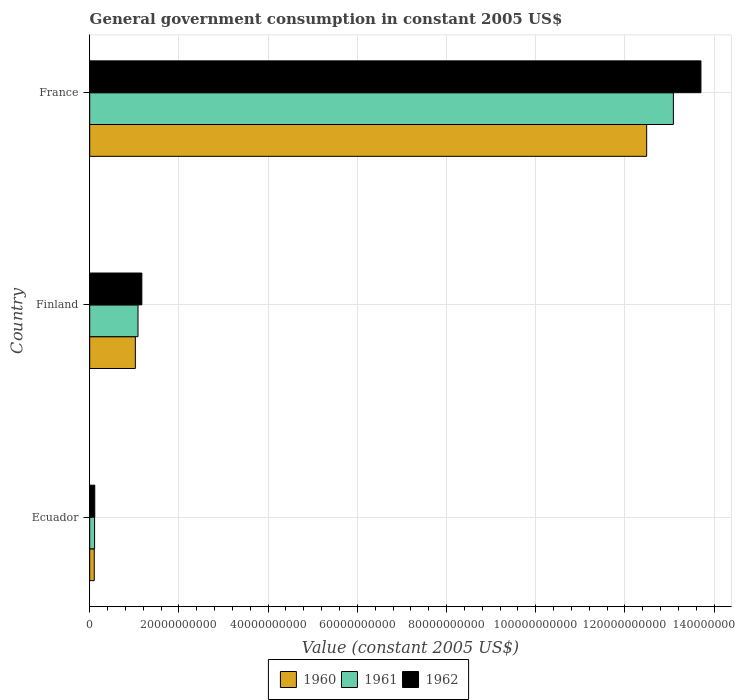How many different coloured bars are there?
Give a very brief answer. 3. How many groups of bars are there?
Offer a terse response. 3. Are the number of bars per tick equal to the number of legend labels?
Your answer should be compact. Yes. Are the number of bars on each tick of the Y-axis equal?
Keep it short and to the point. Yes. What is the label of the 3rd group of bars from the top?
Provide a succinct answer. Ecuador. What is the government conusmption in 1962 in France?
Your answer should be compact. 1.37e+11. Across all countries, what is the maximum government conusmption in 1962?
Ensure brevity in your answer.  1.37e+11. Across all countries, what is the minimum government conusmption in 1961?
Provide a short and direct response. 1.10e+09. In which country was the government conusmption in 1961 maximum?
Keep it short and to the point. France. In which country was the government conusmption in 1962 minimum?
Offer a terse response. Ecuador. What is the total government conusmption in 1960 in the graph?
Offer a terse response. 1.36e+11. What is the difference between the government conusmption in 1960 in Finland and that in France?
Offer a terse response. -1.15e+11. What is the difference between the government conusmption in 1960 in France and the government conusmption in 1961 in Finland?
Provide a succinct answer. 1.14e+11. What is the average government conusmption in 1960 per country?
Offer a very short reply. 4.54e+1. What is the difference between the government conusmption in 1960 and government conusmption in 1962 in Finland?
Provide a succinct answer. -1.46e+09. What is the ratio of the government conusmption in 1961 in Finland to that in France?
Your answer should be compact. 0.08. Is the government conusmption in 1961 in Finland less than that in France?
Offer a terse response. Yes. What is the difference between the highest and the second highest government conusmption in 1961?
Provide a short and direct response. 1.20e+11. What is the difference between the highest and the lowest government conusmption in 1960?
Ensure brevity in your answer.  1.24e+11. In how many countries, is the government conusmption in 1961 greater than the average government conusmption in 1961 taken over all countries?
Give a very brief answer. 1. Is the sum of the government conusmption in 1960 in Finland and France greater than the maximum government conusmption in 1962 across all countries?
Your response must be concise. No. What does the 2nd bar from the top in France represents?
Your answer should be very brief. 1961. Is it the case that in every country, the sum of the government conusmption in 1961 and government conusmption in 1960 is greater than the government conusmption in 1962?
Provide a succinct answer. Yes. Are all the bars in the graph horizontal?
Make the answer very short. Yes. Are the values on the major ticks of X-axis written in scientific E-notation?
Your answer should be very brief. No. Does the graph contain any zero values?
Your answer should be very brief. No. Does the graph contain grids?
Your response must be concise. Yes. Where does the legend appear in the graph?
Make the answer very short. Bottom center. What is the title of the graph?
Offer a terse response. General government consumption in constant 2005 US$. Does "1987" appear as one of the legend labels in the graph?
Your answer should be compact. No. What is the label or title of the X-axis?
Your answer should be compact. Value (constant 2005 US$). What is the Value (constant 2005 US$) of 1960 in Ecuador?
Keep it short and to the point. 1.03e+09. What is the Value (constant 2005 US$) of 1961 in Ecuador?
Provide a succinct answer. 1.10e+09. What is the Value (constant 2005 US$) in 1962 in Ecuador?
Give a very brief answer. 1.14e+09. What is the Value (constant 2005 US$) of 1960 in Finland?
Provide a short and direct response. 1.02e+1. What is the Value (constant 2005 US$) in 1961 in Finland?
Offer a terse response. 1.08e+1. What is the Value (constant 2005 US$) of 1962 in Finland?
Your answer should be very brief. 1.17e+1. What is the Value (constant 2005 US$) of 1960 in France?
Give a very brief answer. 1.25e+11. What is the Value (constant 2005 US$) of 1961 in France?
Offer a very short reply. 1.31e+11. What is the Value (constant 2005 US$) of 1962 in France?
Provide a short and direct response. 1.37e+11. Across all countries, what is the maximum Value (constant 2005 US$) of 1960?
Your answer should be compact. 1.25e+11. Across all countries, what is the maximum Value (constant 2005 US$) in 1961?
Provide a succinct answer. 1.31e+11. Across all countries, what is the maximum Value (constant 2005 US$) of 1962?
Offer a very short reply. 1.37e+11. Across all countries, what is the minimum Value (constant 2005 US$) in 1960?
Ensure brevity in your answer.  1.03e+09. Across all countries, what is the minimum Value (constant 2005 US$) of 1961?
Give a very brief answer. 1.10e+09. Across all countries, what is the minimum Value (constant 2005 US$) in 1962?
Provide a short and direct response. 1.14e+09. What is the total Value (constant 2005 US$) of 1960 in the graph?
Provide a short and direct response. 1.36e+11. What is the total Value (constant 2005 US$) of 1961 in the graph?
Provide a succinct answer. 1.43e+11. What is the total Value (constant 2005 US$) in 1962 in the graph?
Make the answer very short. 1.50e+11. What is the difference between the Value (constant 2005 US$) in 1960 in Ecuador and that in Finland?
Offer a terse response. -9.21e+09. What is the difference between the Value (constant 2005 US$) in 1961 in Ecuador and that in Finland?
Offer a very short reply. -9.73e+09. What is the difference between the Value (constant 2005 US$) of 1962 in Ecuador and that in Finland?
Provide a succinct answer. -1.06e+1. What is the difference between the Value (constant 2005 US$) in 1960 in Ecuador and that in France?
Make the answer very short. -1.24e+11. What is the difference between the Value (constant 2005 US$) of 1961 in Ecuador and that in France?
Provide a short and direct response. -1.30e+11. What is the difference between the Value (constant 2005 US$) in 1962 in Ecuador and that in France?
Make the answer very short. -1.36e+11. What is the difference between the Value (constant 2005 US$) of 1960 in Finland and that in France?
Ensure brevity in your answer.  -1.15e+11. What is the difference between the Value (constant 2005 US$) in 1961 in Finland and that in France?
Offer a very short reply. -1.20e+11. What is the difference between the Value (constant 2005 US$) in 1962 in Finland and that in France?
Your answer should be compact. -1.25e+11. What is the difference between the Value (constant 2005 US$) in 1960 in Ecuador and the Value (constant 2005 US$) in 1961 in Finland?
Ensure brevity in your answer.  -9.81e+09. What is the difference between the Value (constant 2005 US$) in 1960 in Ecuador and the Value (constant 2005 US$) in 1962 in Finland?
Your answer should be compact. -1.07e+1. What is the difference between the Value (constant 2005 US$) in 1961 in Ecuador and the Value (constant 2005 US$) in 1962 in Finland?
Ensure brevity in your answer.  -1.06e+1. What is the difference between the Value (constant 2005 US$) in 1960 in Ecuador and the Value (constant 2005 US$) in 1961 in France?
Keep it short and to the point. -1.30e+11. What is the difference between the Value (constant 2005 US$) in 1960 in Ecuador and the Value (constant 2005 US$) in 1962 in France?
Offer a very short reply. -1.36e+11. What is the difference between the Value (constant 2005 US$) in 1961 in Ecuador and the Value (constant 2005 US$) in 1962 in France?
Keep it short and to the point. -1.36e+11. What is the difference between the Value (constant 2005 US$) of 1960 in Finland and the Value (constant 2005 US$) of 1961 in France?
Your answer should be very brief. -1.21e+11. What is the difference between the Value (constant 2005 US$) in 1960 in Finland and the Value (constant 2005 US$) in 1962 in France?
Ensure brevity in your answer.  -1.27e+11. What is the difference between the Value (constant 2005 US$) in 1961 in Finland and the Value (constant 2005 US$) in 1962 in France?
Ensure brevity in your answer.  -1.26e+11. What is the average Value (constant 2005 US$) in 1960 per country?
Make the answer very short. 4.54e+1. What is the average Value (constant 2005 US$) in 1961 per country?
Make the answer very short. 4.76e+1. What is the average Value (constant 2005 US$) in 1962 per country?
Keep it short and to the point. 5.00e+1. What is the difference between the Value (constant 2005 US$) of 1960 and Value (constant 2005 US$) of 1961 in Ecuador?
Offer a terse response. -7.35e+07. What is the difference between the Value (constant 2005 US$) of 1960 and Value (constant 2005 US$) of 1962 in Ecuador?
Your answer should be compact. -1.12e+08. What is the difference between the Value (constant 2005 US$) of 1961 and Value (constant 2005 US$) of 1962 in Ecuador?
Your answer should be very brief. -3.85e+07. What is the difference between the Value (constant 2005 US$) in 1960 and Value (constant 2005 US$) in 1961 in Finland?
Your response must be concise. -5.98e+08. What is the difference between the Value (constant 2005 US$) in 1960 and Value (constant 2005 US$) in 1962 in Finland?
Make the answer very short. -1.46e+09. What is the difference between the Value (constant 2005 US$) in 1961 and Value (constant 2005 US$) in 1962 in Finland?
Your response must be concise. -8.59e+08. What is the difference between the Value (constant 2005 US$) in 1960 and Value (constant 2005 US$) in 1961 in France?
Your response must be concise. -5.99e+09. What is the difference between the Value (constant 2005 US$) in 1960 and Value (constant 2005 US$) in 1962 in France?
Provide a short and direct response. -1.22e+1. What is the difference between the Value (constant 2005 US$) of 1961 and Value (constant 2005 US$) of 1962 in France?
Offer a very short reply. -6.18e+09. What is the ratio of the Value (constant 2005 US$) of 1960 in Ecuador to that in Finland?
Your answer should be very brief. 0.1. What is the ratio of the Value (constant 2005 US$) of 1961 in Ecuador to that in Finland?
Offer a terse response. 0.1. What is the ratio of the Value (constant 2005 US$) of 1962 in Ecuador to that in Finland?
Provide a succinct answer. 0.1. What is the ratio of the Value (constant 2005 US$) of 1960 in Ecuador to that in France?
Give a very brief answer. 0.01. What is the ratio of the Value (constant 2005 US$) in 1961 in Ecuador to that in France?
Your answer should be very brief. 0.01. What is the ratio of the Value (constant 2005 US$) of 1962 in Ecuador to that in France?
Provide a short and direct response. 0.01. What is the ratio of the Value (constant 2005 US$) in 1960 in Finland to that in France?
Your response must be concise. 0.08. What is the ratio of the Value (constant 2005 US$) in 1961 in Finland to that in France?
Ensure brevity in your answer.  0.08. What is the ratio of the Value (constant 2005 US$) in 1962 in Finland to that in France?
Give a very brief answer. 0.09. What is the difference between the highest and the second highest Value (constant 2005 US$) in 1960?
Your answer should be compact. 1.15e+11. What is the difference between the highest and the second highest Value (constant 2005 US$) in 1961?
Ensure brevity in your answer.  1.20e+11. What is the difference between the highest and the second highest Value (constant 2005 US$) of 1962?
Your answer should be very brief. 1.25e+11. What is the difference between the highest and the lowest Value (constant 2005 US$) in 1960?
Offer a very short reply. 1.24e+11. What is the difference between the highest and the lowest Value (constant 2005 US$) of 1961?
Give a very brief answer. 1.30e+11. What is the difference between the highest and the lowest Value (constant 2005 US$) in 1962?
Give a very brief answer. 1.36e+11. 